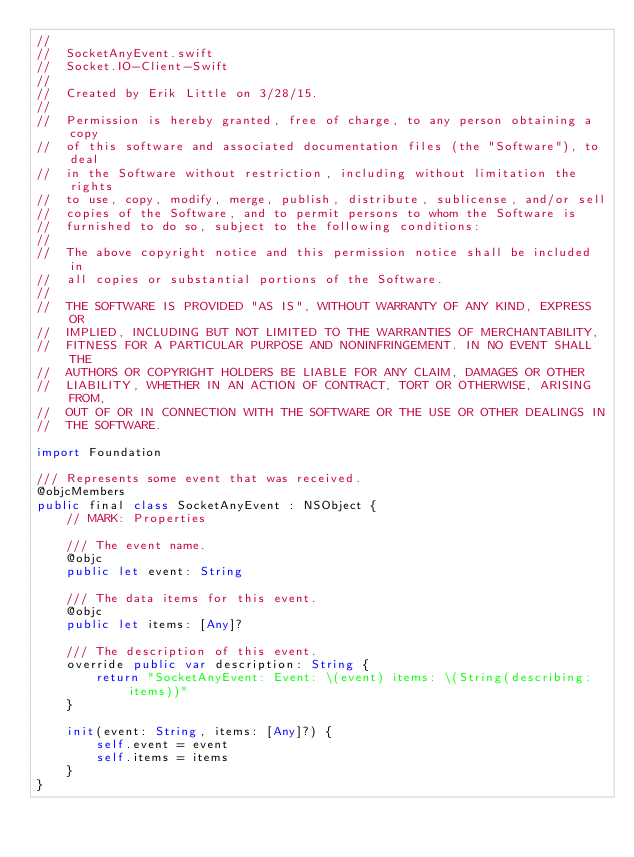<code> <loc_0><loc_0><loc_500><loc_500><_Swift_>//
//  SocketAnyEvent.swift
//  Socket.IO-Client-Swift
//
//  Created by Erik Little on 3/28/15.
//
//  Permission is hereby granted, free of charge, to any person obtaining a copy
//  of this software and associated documentation files (the "Software"), to deal
//  in the Software without restriction, including without limitation the rights
//  to use, copy, modify, merge, publish, distribute, sublicense, and/or sell
//  copies of the Software, and to permit persons to whom the Software is
//  furnished to do so, subject to the following conditions:
//
//  The above copyright notice and this permission notice shall be included in
//  all copies or substantial portions of the Software.
//
//  THE SOFTWARE IS PROVIDED "AS IS", WITHOUT WARRANTY OF ANY KIND, EXPRESS OR
//  IMPLIED, INCLUDING BUT NOT LIMITED TO THE WARRANTIES OF MERCHANTABILITY,
//  FITNESS FOR A PARTICULAR PURPOSE AND NONINFRINGEMENT. IN NO EVENT SHALL THE
//  AUTHORS OR COPYRIGHT HOLDERS BE LIABLE FOR ANY CLAIM, DAMAGES OR OTHER
//  LIABILITY, WHETHER IN AN ACTION OF CONTRACT, TORT OR OTHERWISE, ARISING FROM,
//  OUT OF OR IN CONNECTION WITH THE SOFTWARE OR THE USE OR OTHER DEALINGS IN
//  THE SOFTWARE.

import Foundation

/// Represents some event that was received.
@objcMembers
public final class SocketAnyEvent : NSObject {
    // MARK: Properties

    /// The event name.
    @objc
    public let event: String

    /// The data items for this event.
    @objc
    public let items: [Any]?

    /// The description of this event.
    override public var description: String {
        return "SocketAnyEvent: Event: \(event) items: \(String(describing: items))"
    }

    init(event: String, items: [Any]?) {
        self.event = event
        self.items = items
    }
}
</code> 